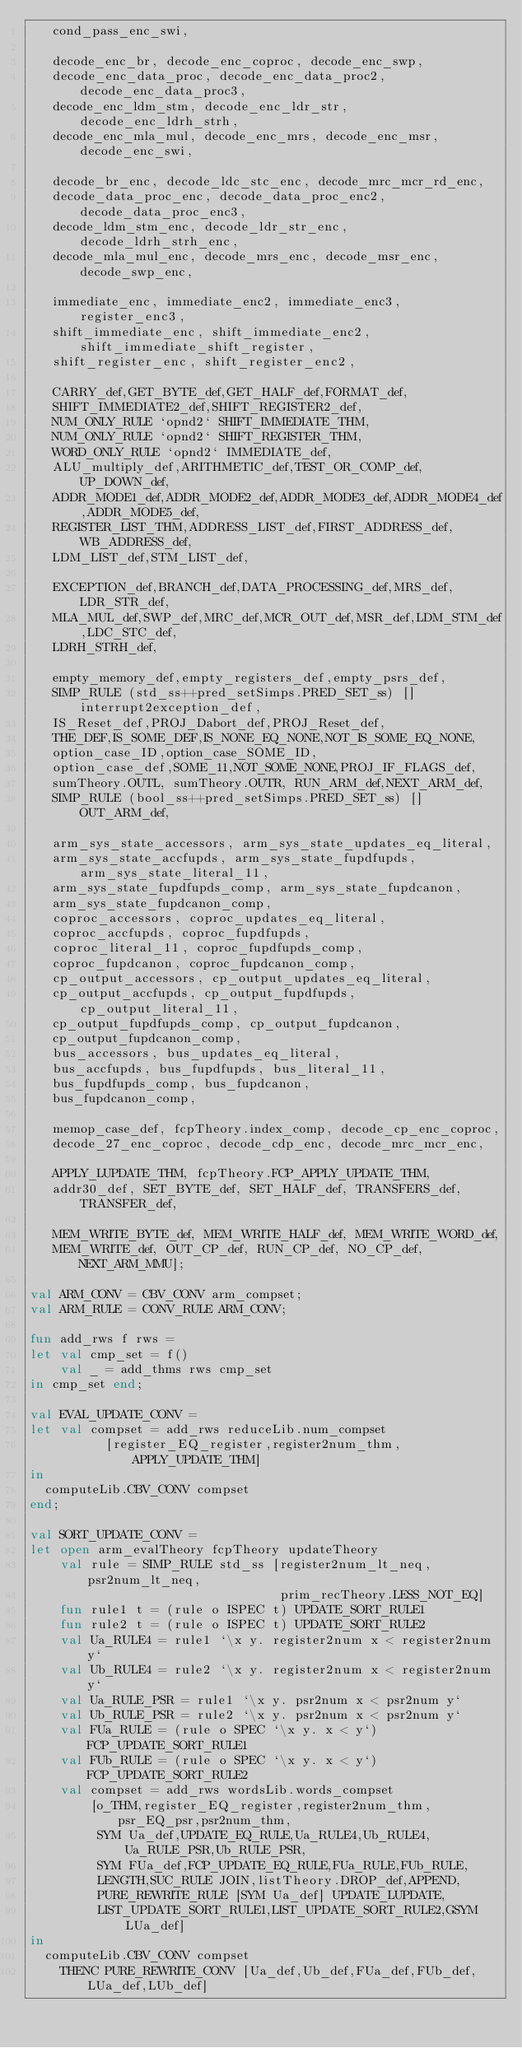<code> <loc_0><loc_0><loc_500><loc_500><_SML_>   cond_pass_enc_swi,

   decode_enc_br, decode_enc_coproc, decode_enc_swp,
   decode_enc_data_proc, decode_enc_data_proc2, decode_enc_data_proc3,
   decode_enc_ldm_stm, decode_enc_ldr_str, decode_enc_ldrh_strh,
   decode_enc_mla_mul, decode_enc_mrs, decode_enc_msr, decode_enc_swi,

   decode_br_enc, decode_ldc_stc_enc, decode_mrc_mcr_rd_enc,
   decode_data_proc_enc, decode_data_proc_enc2, decode_data_proc_enc3,
   decode_ldm_stm_enc, decode_ldr_str_enc, decode_ldrh_strh_enc,
   decode_mla_mul_enc, decode_mrs_enc, decode_msr_enc, decode_swp_enc,

   immediate_enc, immediate_enc2, immediate_enc3, register_enc3,
   shift_immediate_enc, shift_immediate_enc2, shift_immediate_shift_register,
   shift_register_enc, shift_register_enc2,

   CARRY_def,GET_BYTE_def,GET_HALF_def,FORMAT_def,
   SHIFT_IMMEDIATE2_def,SHIFT_REGISTER2_def,
   NUM_ONLY_RULE `opnd2` SHIFT_IMMEDIATE_THM,
   NUM_ONLY_RULE `opnd2` SHIFT_REGISTER_THM,
   WORD_ONLY_RULE `opnd2` IMMEDIATE_def,
   ALU_multiply_def,ARITHMETIC_def,TEST_OR_COMP_def,UP_DOWN_def,
   ADDR_MODE1_def,ADDR_MODE2_def,ADDR_MODE3_def,ADDR_MODE4_def,ADDR_MODE5_def,
   REGISTER_LIST_THM,ADDRESS_LIST_def,FIRST_ADDRESS_def,WB_ADDRESS_def,
   LDM_LIST_def,STM_LIST_def,

   EXCEPTION_def,BRANCH_def,DATA_PROCESSING_def,MRS_def,LDR_STR_def,
   MLA_MUL_def,SWP_def,MRC_def,MCR_OUT_def,MSR_def,LDM_STM_def,LDC_STC_def,
   LDRH_STRH_def,

   empty_memory_def,empty_registers_def,empty_psrs_def,
   SIMP_RULE (std_ss++pred_setSimps.PRED_SET_ss) [] interrupt2exception_def,
   IS_Reset_def,PROJ_Dabort_def,PROJ_Reset_def,
   THE_DEF,IS_SOME_DEF,IS_NONE_EQ_NONE,NOT_IS_SOME_EQ_NONE,
   option_case_ID,option_case_SOME_ID,
   option_case_def,SOME_11,NOT_SOME_NONE,PROJ_IF_FLAGS_def,
   sumTheory.OUTL, sumTheory.OUTR, RUN_ARM_def,NEXT_ARM_def,
   SIMP_RULE (bool_ss++pred_setSimps.PRED_SET_ss) [] OUT_ARM_def,

   arm_sys_state_accessors, arm_sys_state_updates_eq_literal,
   arm_sys_state_accfupds, arm_sys_state_fupdfupds, arm_sys_state_literal_11,
   arm_sys_state_fupdfupds_comp, arm_sys_state_fupdcanon,
   arm_sys_state_fupdcanon_comp,
   coproc_accessors, coproc_updates_eq_literal,
   coproc_accfupds, coproc_fupdfupds,
   coproc_literal_11, coproc_fupdfupds_comp,
   coproc_fupdcanon, coproc_fupdcanon_comp,
   cp_output_accessors, cp_output_updates_eq_literal,
   cp_output_accfupds, cp_output_fupdfupds, cp_output_literal_11,
   cp_output_fupdfupds_comp, cp_output_fupdcanon,
   cp_output_fupdcanon_comp,
   bus_accessors, bus_updates_eq_literal,
   bus_accfupds, bus_fupdfupds, bus_literal_11,
   bus_fupdfupds_comp, bus_fupdcanon,
   bus_fupdcanon_comp,

   memop_case_def, fcpTheory.index_comp, decode_cp_enc_coproc,
   decode_27_enc_coproc, decode_cdp_enc, decode_mrc_mcr_enc,

   APPLY_LUPDATE_THM, fcpTheory.FCP_APPLY_UPDATE_THM,
   addr30_def, SET_BYTE_def, SET_HALF_def, TRANSFERS_def, TRANSFER_def,

   MEM_WRITE_BYTE_def, MEM_WRITE_HALF_def, MEM_WRITE_WORD_def,
   MEM_WRITE_def, OUT_CP_def, RUN_CP_def, NO_CP_def, NEXT_ARM_MMU];

val ARM_CONV = CBV_CONV arm_compset;
val ARM_RULE = CONV_RULE ARM_CONV;

fun add_rws f rws =
let val cmp_set = f()
    val _ = add_thms rws cmp_set
in cmp_set end;

val EVAL_UPDATE_CONV =
let val compset = add_rws reduceLib.num_compset
          [register_EQ_register,register2num_thm,APPLY_UPDATE_THM]
in
  computeLib.CBV_CONV compset
end;

val SORT_UPDATE_CONV =
let open arm_evalTheory fcpTheory updateTheory
    val rule = SIMP_RULE std_ss [register2num_lt_neq, psr2num_lt_neq,
                                 prim_recTheory.LESS_NOT_EQ]
    fun rule1 t = (rule o ISPEC t) UPDATE_SORT_RULE1
    fun rule2 t = (rule o ISPEC t) UPDATE_SORT_RULE2
    val Ua_RULE4 = rule1 `\x y. register2num x < register2num y`
    val Ub_RULE4 = rule2 `\x y. register2num x < register2num y`
    val Ua_RULE_PSR = rule1 `\x y. psr2num x < psr2num y`
    val Ub_RULE_PSR = rule2 `\x y. psr2num x < psr2num y`
    val FUa_RULE = (rule o SPEC `\x y. x < y`) FCP_UPDATE_SORT_RULE1
    val FUb_RULE = (rule o SPEC `\x y. x < y`) FCP_UPDATE_SORT_RULE2
    val compset = add_rws wordsLib.words_compset
        [o_THM,register_EQ_register,register2num_thm,psr_EQ_psr,psr2num_thm,
         SYM Ua_def,UPDATE_EQ_RULE,Ua_RULE4,Ub_RULE4,Ua_RULE_PSR,Ub_RULE_PSR,
         SYM FUa_def,FCP_UPDATE_EQ_RULE,FUa_RULE,FUb_RULE,
         LENGTH,SUC_RULE JOIN,listTheory.DROP_def,APPEND,
         PURE_REWRITE_RULE [SYM Ua_def] UPDATE_LUPDATE,
         LIST_UPDATE_SORT_RULE1,LIST_UPDATE_SORT_RULE2,GSYM LUa_def]
in
  computeLib.CBV_CONV compset
    THENC PURE_REWRITE_CONV [Ua_def,Ub_def,FUa_def,FUb_def,LUa_def,LUb_def]</code> 